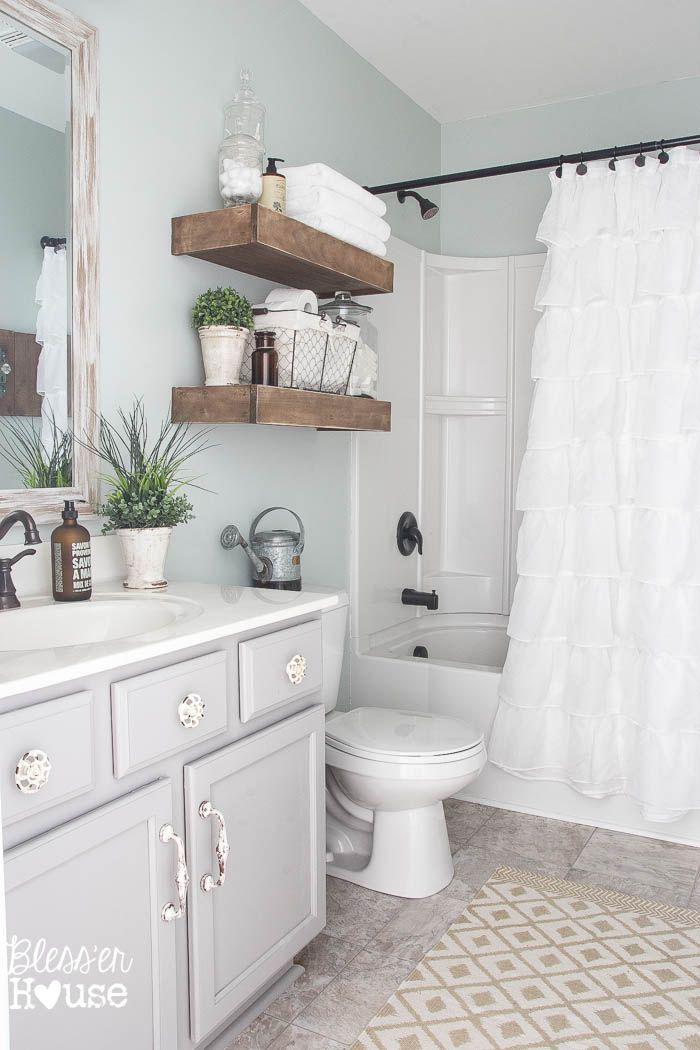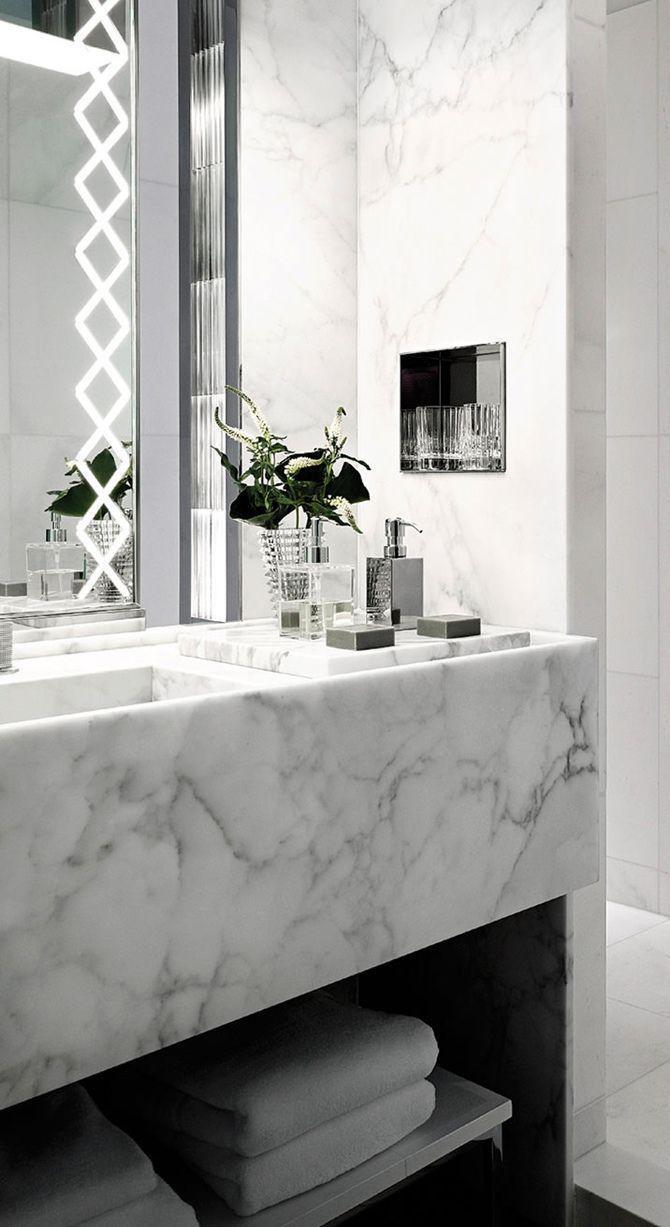The first image is the image on the left, the second image is the image on the right. Analyze the images presented: Is the assertion "The left and right image contains the same number folded towels." valid? Answer yes or no. No. 